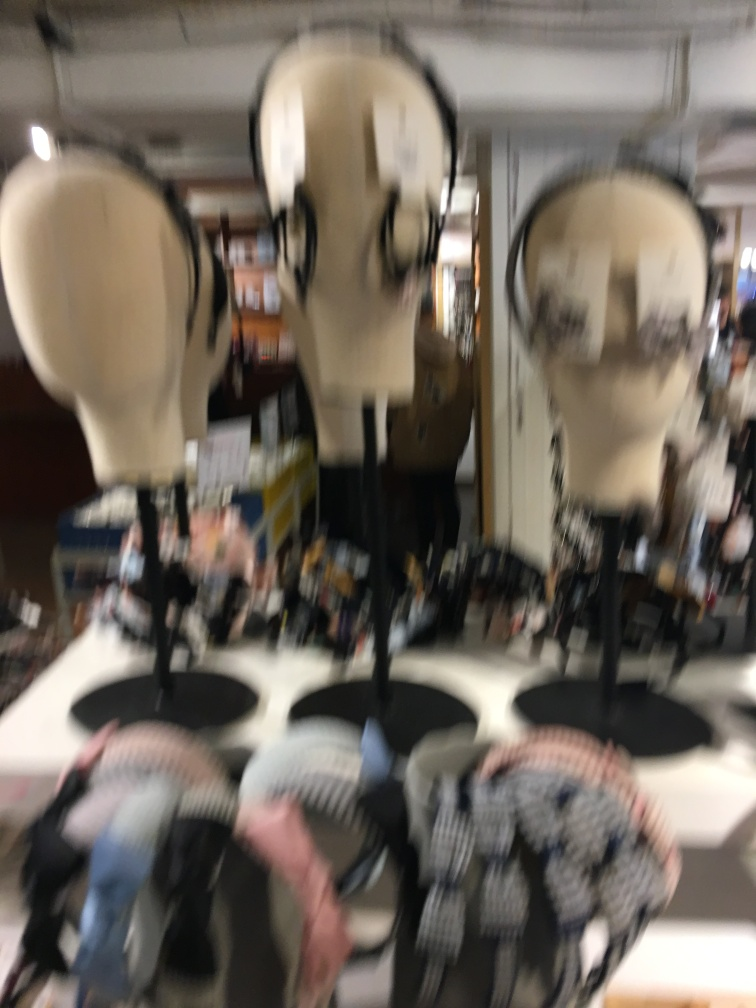How might this image's blur affect a viewer's interpretation? The blur can invoke various interpretations, ranging from a sense of movement or chaos to a hazy recollection or dream-like quality. It can also lead to a feeling of mystery or intrigue, leaving the viewer curious about the obscured details. 